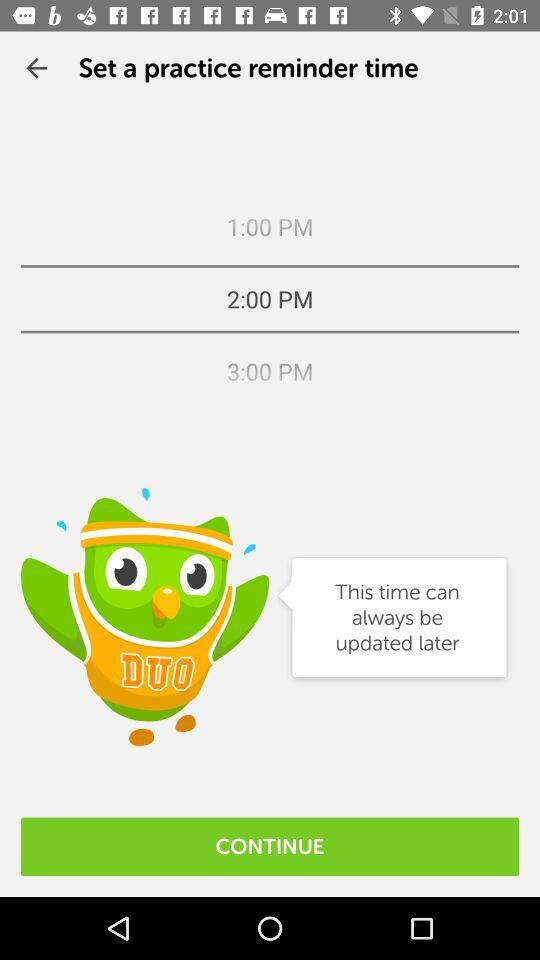Which days are selected for the practice reminder?
When the provided information is insufficient, respond with <no answer>. <no answer> 